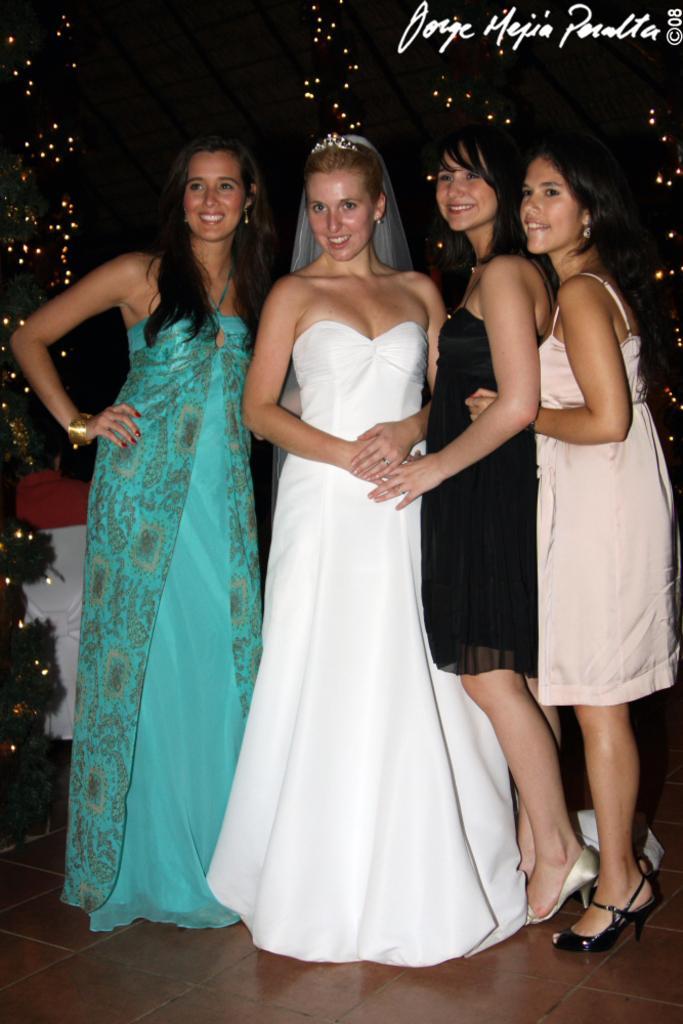Could you give a brief overview of what you see in this image? In this picture there are four women standing and there is something written in the right top corner. 